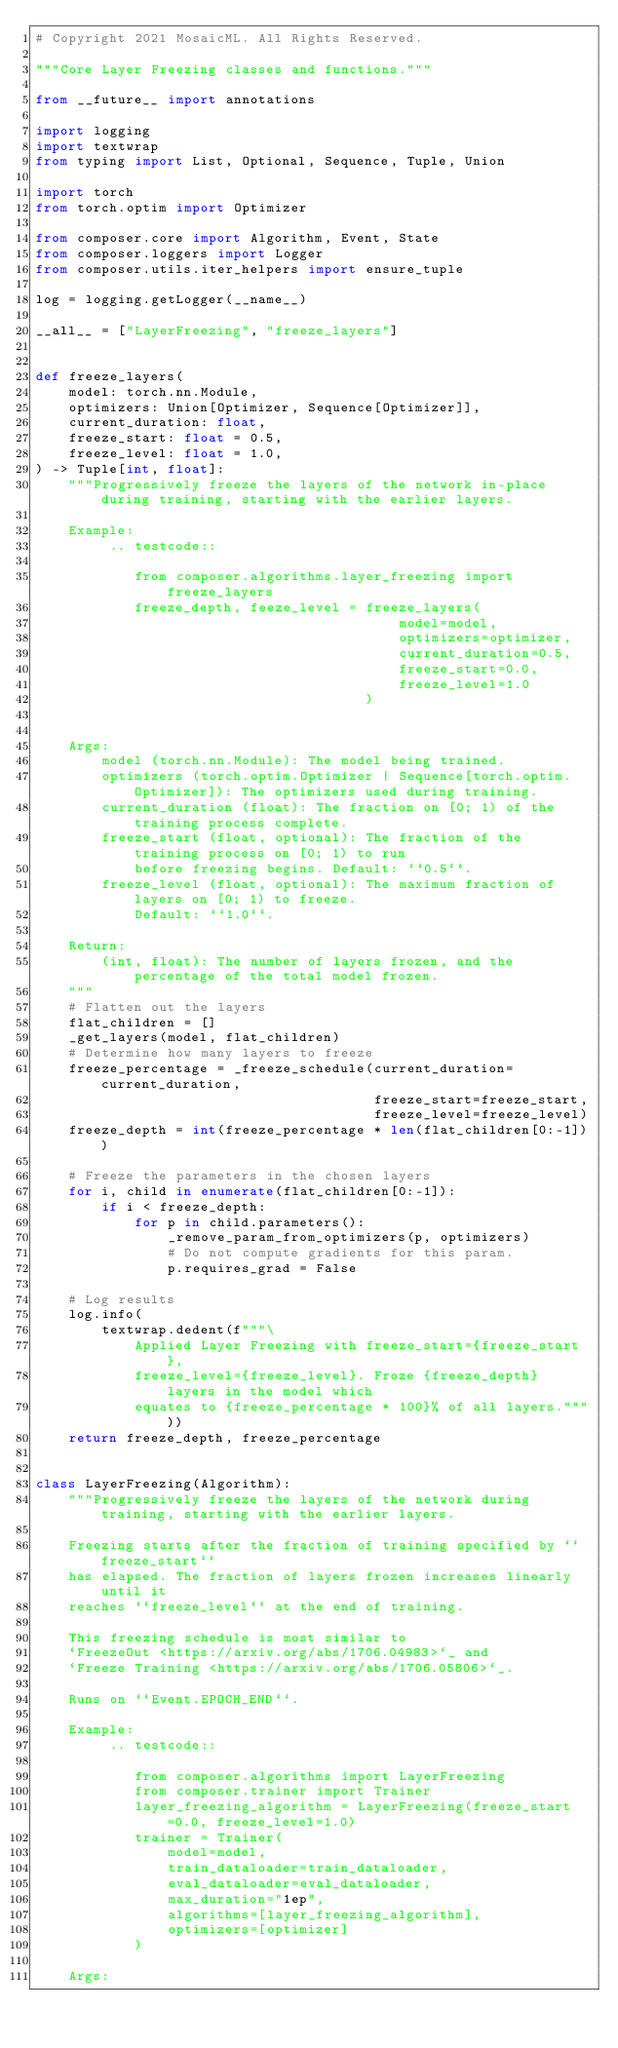Convert code to text. <code><loc_0><loc_0><loc_500><loc_500><_Python_># Copyright 2021 MosaicML. All Rights Reserved.

"""Core Layer Freezing classes and functions."""

from __future__ import annotations

import logging
import textwrap
from typing import List, Optional, Sequence, Tuple, Union

import torch
from torch.optim import Optimizer

from composer.core import Algorithm, Event, State
from composer.loggers import Logger
from composer.utils.iter_helpers import ensure_tuple

log = logging.getLogger(__name__)

__all__ = ["LayerFreezing", "freeze_layers"]


def freeze_layers(
    model: torch.nn.Module,
    optimizers: Union[Optimizer, Sequence[Optimizer]],
    current_duration: float,
    freeze_start: float = 0.5,
    freeze_level: float = 1.0,
) -> Tuple[int, float]:
    """Progressively freeze the layers of the network in-place during training, starting with the earlier layers.

    Example:
         .. testcode::

            from composer.algorithms.layer_freezing import freeze_layers
            freeze_depth, feeze_level = freeze_layers(
                                            model=model,
                                            optimizers=optimizer,
                                            current_duration=0.5,
                                            freeze_start=0.0,
                                            freeze_level=1.0
                                        )


    Args:
        model (torch.nn.Module): The model being trained.
        optimizers (torch.optim.Optimizer | Sequence[torch.optim.Optimizer]): The optimizers used during training.
        current_duration (float): The fraction on [0; 1) of the training process complete.
        freeze_start (float, optional): The fraction of the training process on [0; 1) to run
            before freezing begins. Default: ``0.5``.
        freeze_level (float, optional): The maximum fraction of layers on [0; 1) to freeze.
            Default: ``1.0``.

    Return:
        (int, float): The number of layers frozen, and the percentage of the total model frozen.
    """
    # Flatten out the layers
    flat_children = []
    _get_layers(model, flat_children)
    # Determine how many layers to freeze
    freeze_percentage = _freeze_schedule(current_duration=current_duration,
                                         freeze_start=freeze_start,
                                         freeze_level=freeze_level)
    freeze_depth = int(freeze_percentage * len(flat_children[0:-1]))

    # Freeze the parameters in the chosen layers
    for i, child in enumerate(flat_children[0:-1]):
        if i < freeze_depth:
            for p in child.parameters():
                _remove_param_from_optimizers(p, optimizers)
                # Do not compute gradients for this param.
                p.requires_grad = False

    # Log results
    log.info(
        textwrap.dedent(f"""\
            Applied Layer Freezing with freeze_start={freeze_start},
            freeze_level={freeze_level}. Froze {freeze_depth} layers in the model which
            equates to {freeze_percentage * 100}% of all layers."""))
    return freeze_depth, freeze_percentage


class LayerFreezing(Algorithm):
    """Progressively freeze the layers of the network during training, starting with the earlier layers.

    Freezing starts after the fraction of training specified by ``freeze_start``
    has elapsed. The fraction of layers frozen increases linearly until it
    reaches ``freeze_level`` at the end of training.

    This freezing schedule is most similar to
    `FreezeOut <https://arxiv.org/abs/1706.04983>`_ and
    `Freeze Training <https://arxiv.org/abs/1706.05806>`_.

    Runs on ``Event.EPOCH_END``.

    Example:
         .. testcode::

            from composer.algorithms import LayerFreezing
            from composer.trainer import Trainer
            layer_freezing_algorithm = LayerFreezing(freeze_start=0.0, freeze_level=1.0)
            trainer = Trainer(
                model=model,
                train_dataloader=train_dataloader,
                eval_dataloader=eval_dataloader,
                max_duration="1ep",
                algorithms=[layer_freezing_algorithm],
                optimizers=[optimizer]
            )

    Args:</code> 